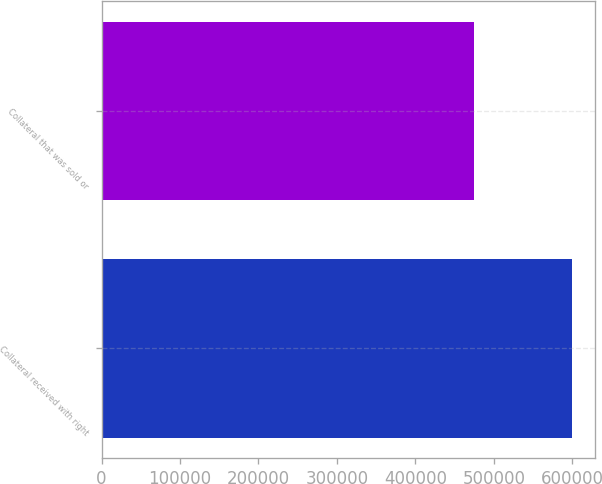Convert chart. <chart><loc_0><loc_0><loc_500><loc_500><bar_chart><fcel>Collateral received with right<fcel>Collateral that was sold or<nl><fcel>599244<fcel>475113<nl></chart> 